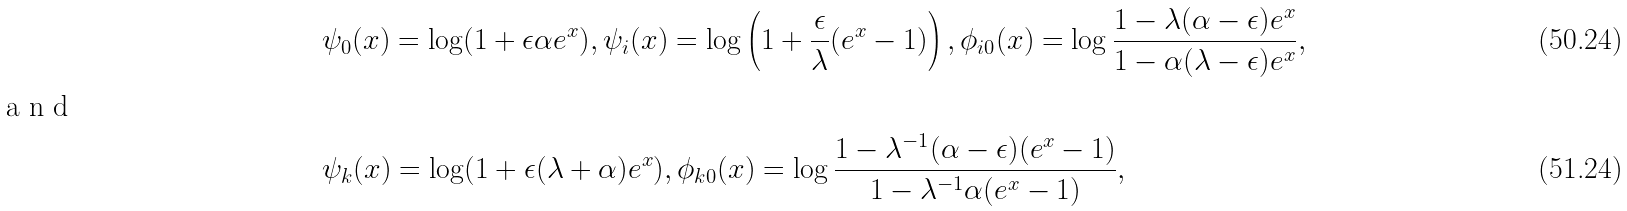<formula> <loc_0><loc_0><loc_500><loc_500>& \psi _ { 0 } ( x ) = \log ( 1 + \epsilon \alpha e ^ { x } ) , \psi _ { i } ( x ) = \log \left ( 1 + \frac { \epsilon } { \lambda } ( e ^ { x } - 1 ) \right ) , \phi _ { i 0 } ( x ) = \log \frac { 1 - \lambda ( \alpha - \epsilon ) e ^ { x } } { 1 - \alpha ( \lambda - \epsilon ) e ^ { x } } , \\ \intertext { a n d } & \psi _ { k } ( x ) = \log ( 1 + \epsilon ( \lambda + \alpha ) e ^ { x } ) , \phi _ { k 0 } ( x ) = \log \frac { 1 - \lambda ^ { - 1 } ( \alpha - \epsilon ) ( e ^ { x } - 1 ) } { 1 - \lambda ^ { - 1 } \alpha ( e ^ { x } - 1 ) } ,</formula> 